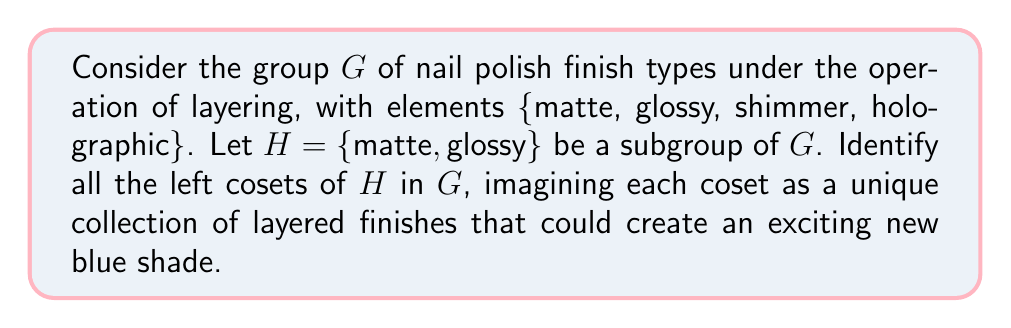Can you answer this question? To find the left cosets of subgroup $H$ in group $G$, we need to multiply each element of $G$ by $H$ from the left. Let's go through this step-by-step:

1) First, recall that a left coset of $H$ in $G$ is defined as $gH = \{gh : h \in H\}$ for some $g \in G$.

2) We need to find $gH$ for each $g \in G$:

   a) For $g = matte$:
      $matte \cdot H = \{matte \cdot matte, matte \cdot glossy\} = \{matte, glossy\} = H$

   b) For $g = glossy$:
      $glossy \cdot H = \{glossy \cdot matte, glossy \cdot glossy\} = \{glossy, glossy\} = \{glossy\} = H$

   c) For $g = shimmer$:
      $shimmer \cdot H = \{shimmer \cdot matte, shimmer \cdot glossy\} = \{shimmer, shimmer\} = \{shimmer\}$

   d) For $g = holographic$:
      $holographic \cdot H = \{holographic \cdot matte, holographic \cdot glossy\} = \{holographic, holographic\} = \{holographic\}$

3) We can see that $matte \cdot H = glossy \cdot H = H$, while $shimmer \cdot H$ and $holographic \cdot H$ are distinct cosets.

4) Therefore, we have identified three distinct left cosets:
   - $H = \{matte, glossy\}$
   - $shimmer \cdot H = \{shimmer\}$
   - $holographic \cdot H = \{holographic\}$

Each of these cosets represents a unique collection of layered finishes that could potentially create an exciting new blue shade.
Answer: The left cosets of $H$ in $G$ are:
$$H = \{matte, glossy\}$$
$$shimmer \cdot H = \{shimmer\}$$
$$holographic \cdot H = \{holographic\}$$ 